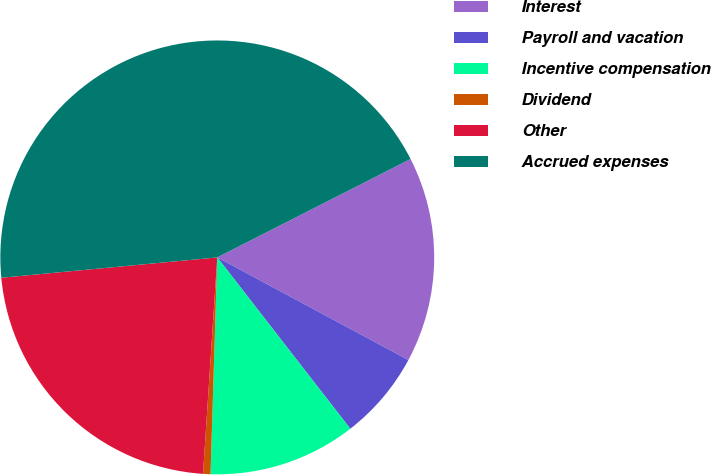Convert chart to OTSL. <chart><loc_0><loc_0><loc_500><loc_500><pie_chart><fcel>Interest<fcel>Payroll and vacation<fcel>Incentive compensation<fcel>Dividend<fcel>Other<fcel>Accrued expenses<nl><fcel>15.34%<fcel>6.65%<fcel>11.0%<fcel>0.55%<fcel>22.46%<fcel>44.0%<nl></chart> 